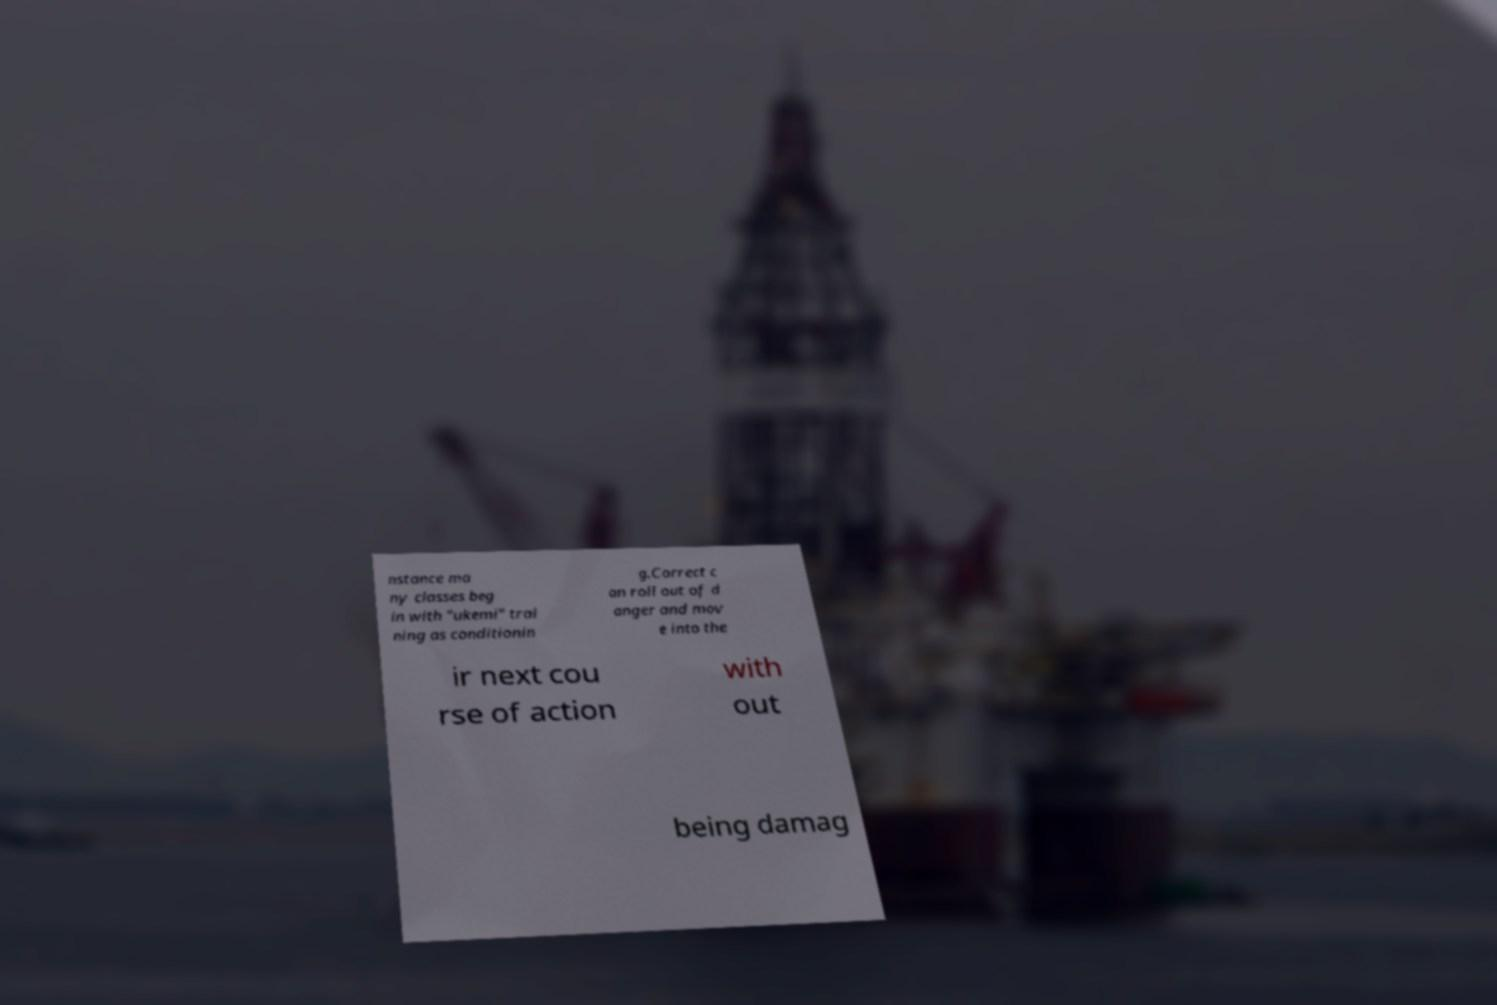What messages or text are displayed in this image? I need them in a readable, typed format. nstance ma ny classes beg in with "ukemi" trai ning as conditionin g.Correct c an roll out of d anger and mov e into the ir next cou rse of action with out being damag 